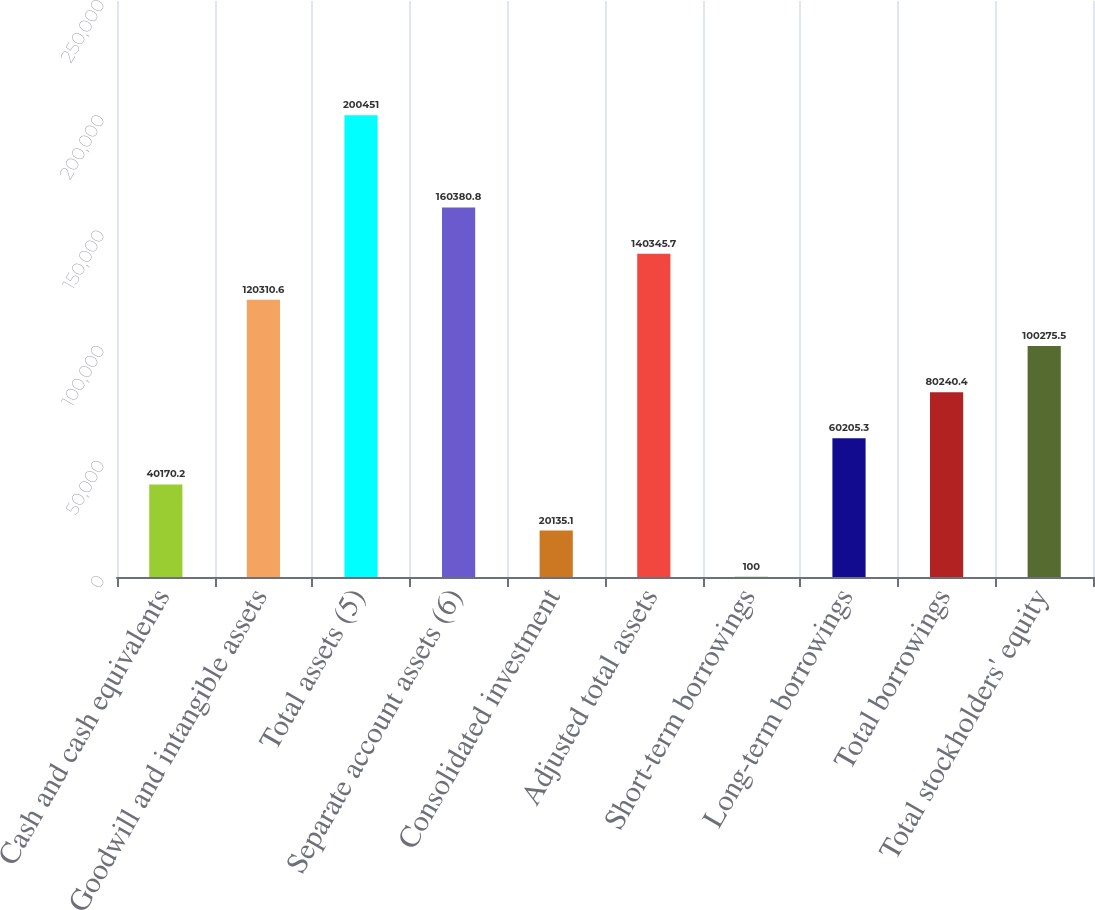Convert chart to OTSL. <chart><loc_0><loc_0><loc_500><loc_500><bar_chart><fcel>Cash and cash equivalents<fcel>Goodwill and intangible assets<fcel>Total assets (5)<fcel>Separate account assets (6)<fcel>Consolidated investment<fcel>Adjusted total assets<fcel>Short-term borrowings<fcel>Long-term borrowings<fcel>Total borrowings<fcel>Total stockholders' equity<nl><fcel>40170.2<fcel>120311<fcel>200451<fcel>160381<fcel>20135.1<fcel>140346<fcel>100<fcel>60205.3<fcel>80240.4<fcel>100276<nl></chart> 